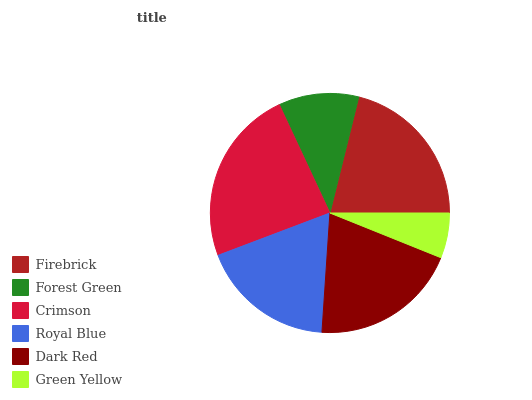Is Green Yellow the minimum?
Answer yes or no. Yes. Is Crimson the maximum?
Answer yes or no. Yes. Is Forest Green the minimum?
Answer yes or no. No. Is Forest Green the maximum?
Answer yes or no. No. Is Firebrick greater than Forest Green?
Answer yes or no. Yes. Is Forest Green less than Firebrick?
Answer yes or no. Yes. Is Forest Green greater than Firebrick?
Answer yes or no. No. Is Firebrick less than Forest Green?
Answer yes or no. No. Is Dark Red the high median?
Answer yes or no. Yes. Is Royal Blue the low median?
Answer yes or no. Yes. Is Royal Blue the high median?
Answer yes or no. No. Is Dark Red the low median?
Answer yes or no. No. 